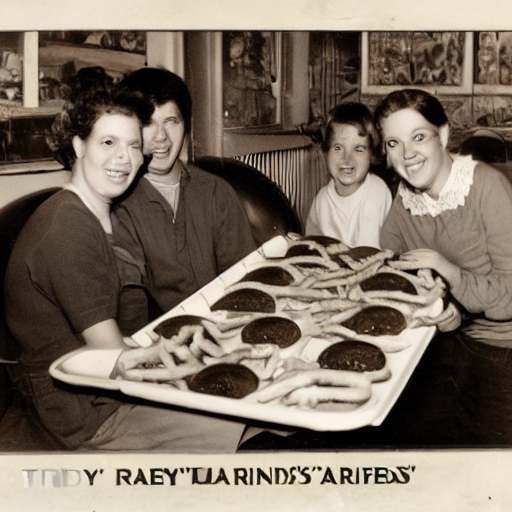Do you think this is a candid photo or a staged one? Why? The photo seems to be staged, as the individuals are directly facing the camera with posed smiles and the food is presented prominently. This setup, along with the quality and framing of the shot, implies that the photograph was likely taken purposefully for a specific occasion or marketing purpose. 